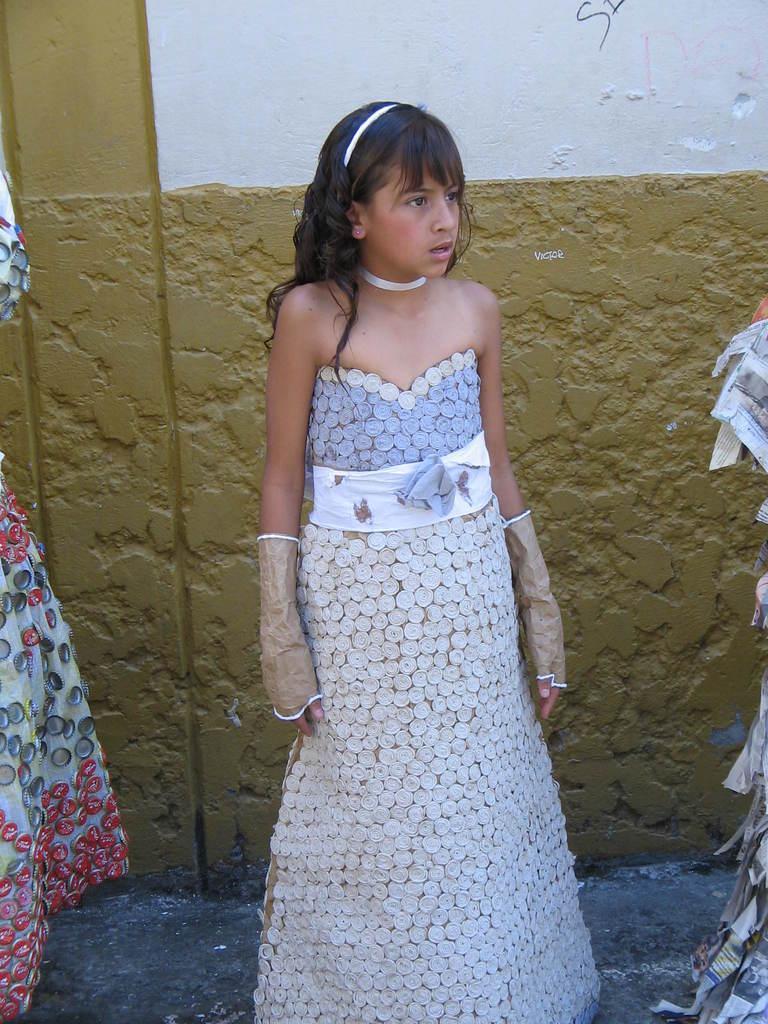Describe this image in one or two sentences. In this image we can see a girl is standing on the ground. On the right side we can see papers and on the left side we can see the dress. In the background we can see the wall. 